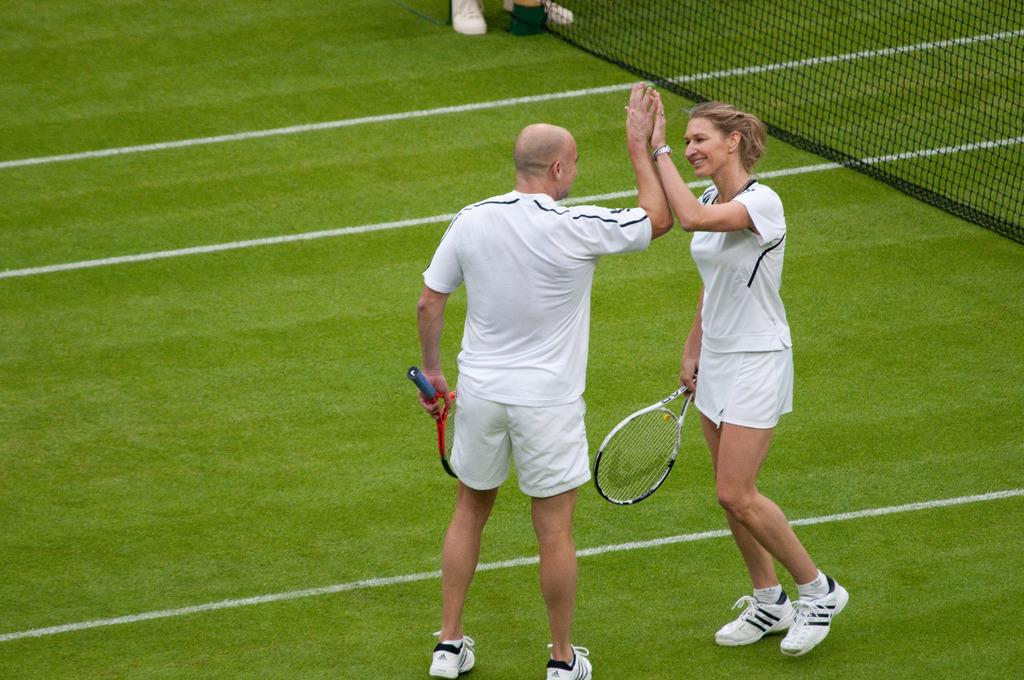How many people are present in the image? There are two people in the image, a man and a woman. What are the man and the woman doing in the image? Both the man and the woman are standing on the ground and holding a bat in their hands. What is the position of the man and the woman in relation to each other? The man and the woman are standing next to each other in the image. What type of orange is being used as a prop in the image? There is no orange present in the image; the man and the woman are holding a bat. What is the goose doing in the image? There is no goose present in the image; the image features a man and a woman holding a bat. 